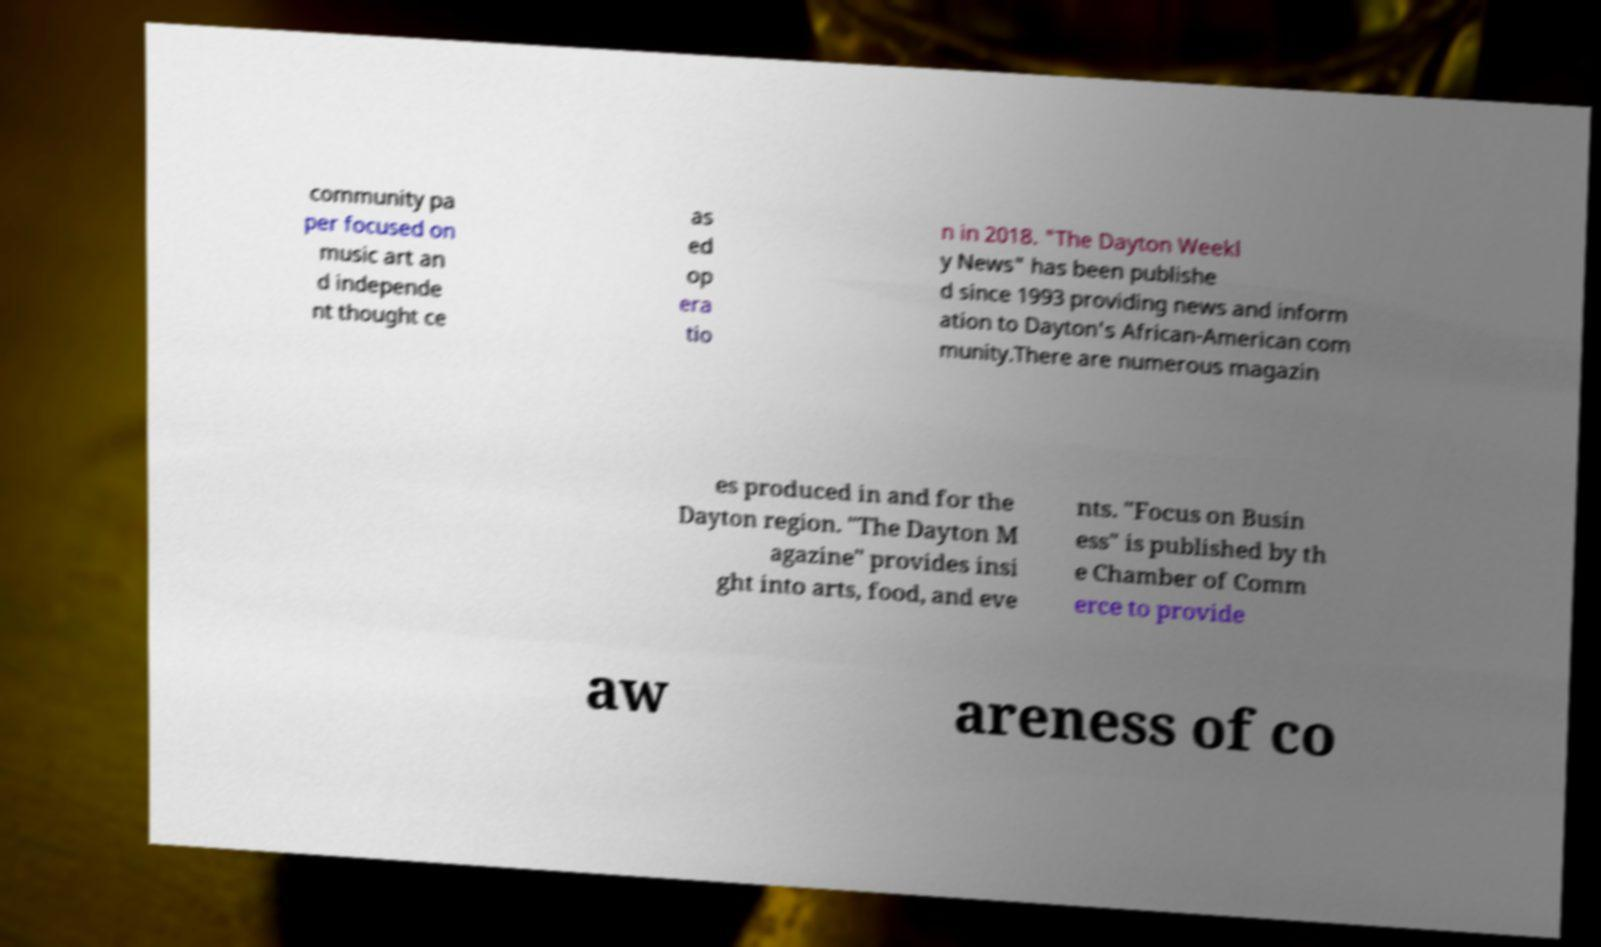There's text embedded in this image that I need extracted. Can you transcribe it verbatim? community pa per focused on music art an d independe nt thought ce as ed op era tio n in 2018. "The Dayton Weekl y News" has been publishe d since 1993 providing news and inform ation to Dayton's African-American com munity.There are numerous magazin es produced in and for the Dayton region. "The Dayton M agazine" provides insi ght into arts, food, and eve nts. "Focus on Busin ess" is published by th e Chamber of Comm erce to provide aw areness of co 